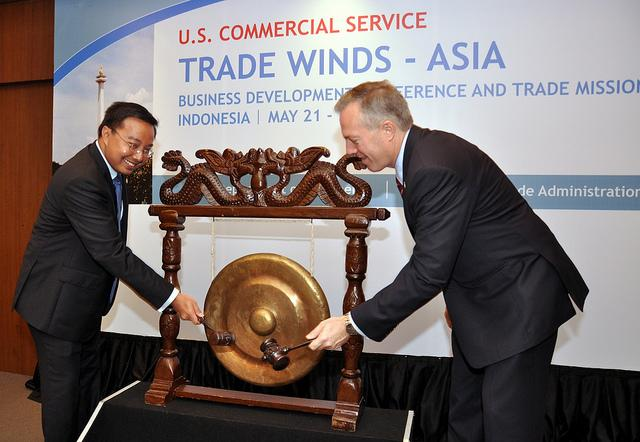What does hitting the gong here signal? Please explain your reasoning. opening. Gongs are commonly used as ceremonial instruments. 